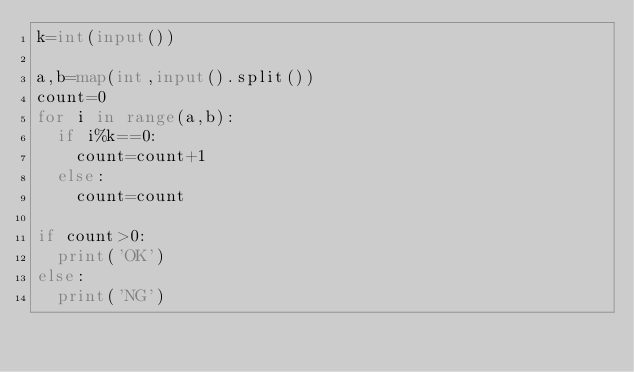<code> <loc_0><loc_0><loc_500><loc_500><_Python_>k=int(input())

a,b=map(int,input().split())
count=0
for i in range(a,b):
  if i%k==0:
    count=count+1
  else:
    count=count
    
if count>0:
  print('OK')
else:
  print('NG')</code> 